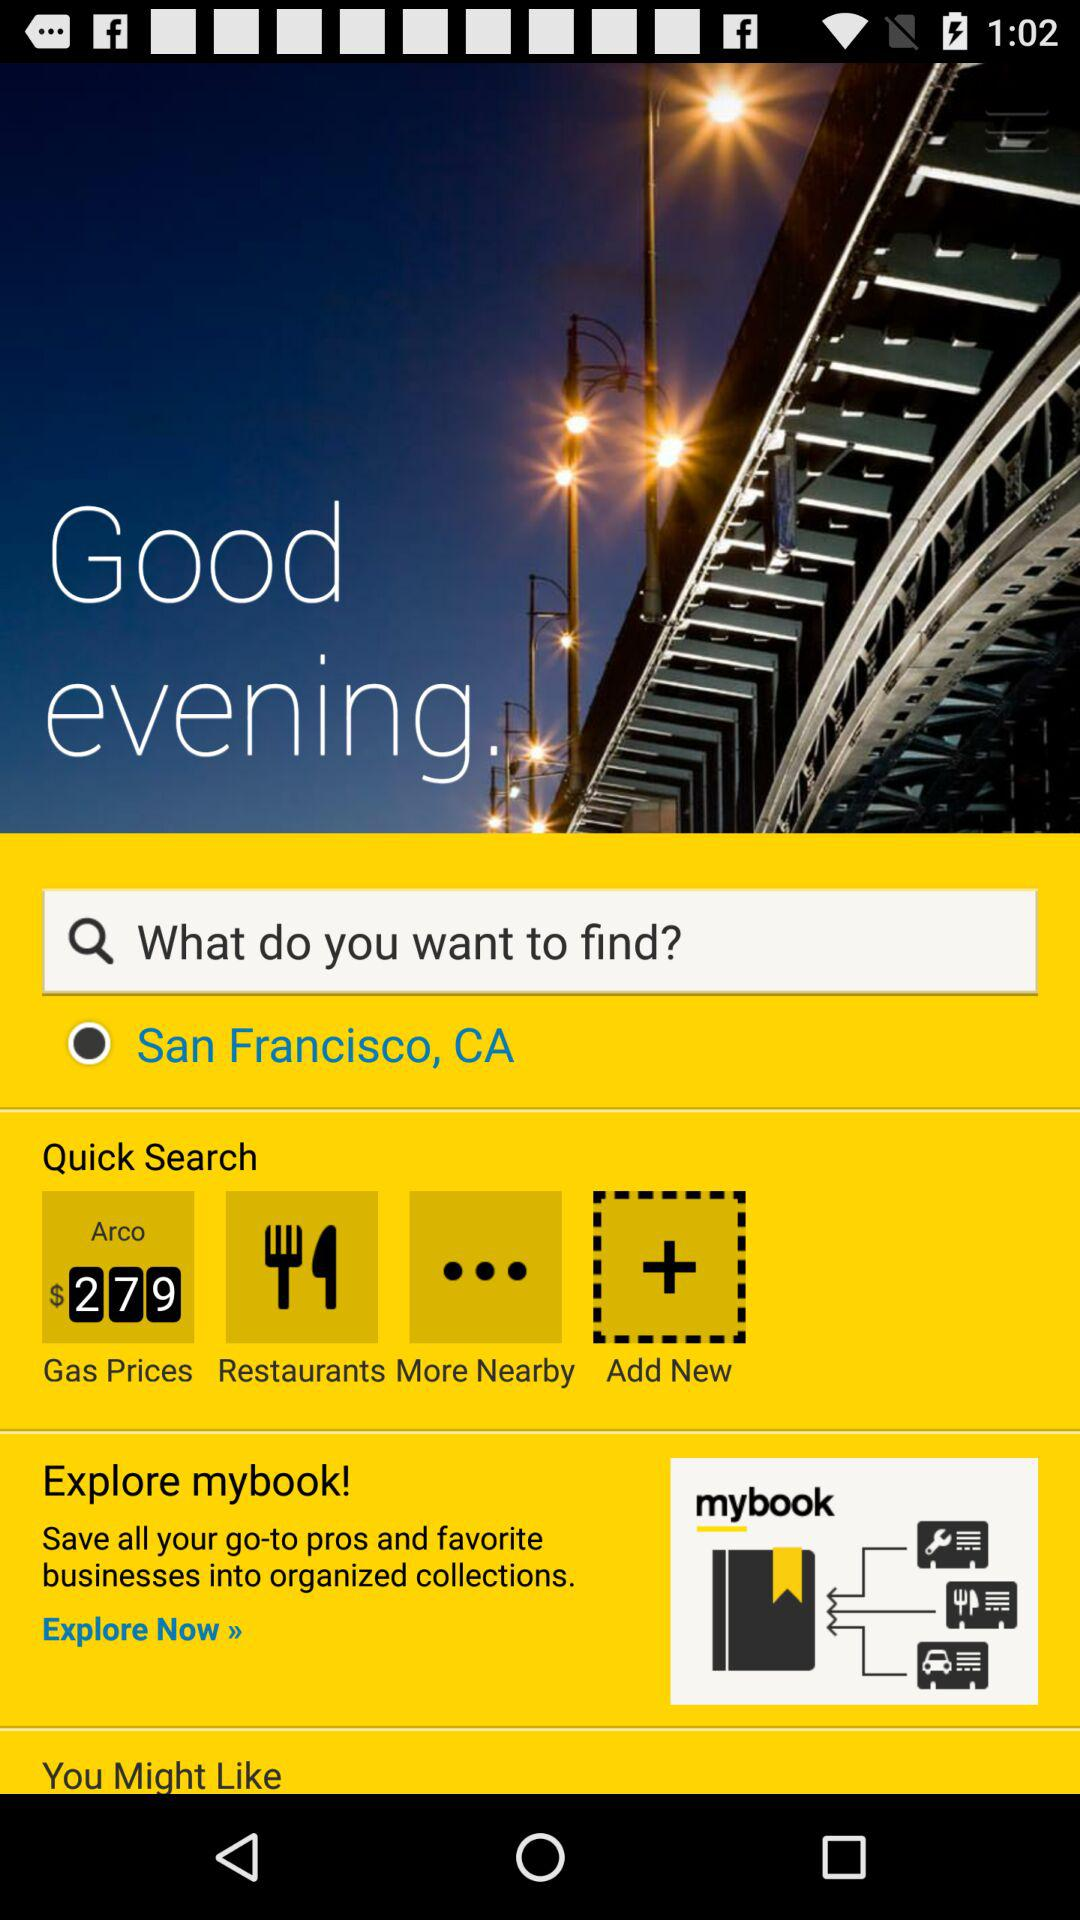What are the Quick Search options? The options are "Gas Prices", "Restaurants" and "More Nearby". 